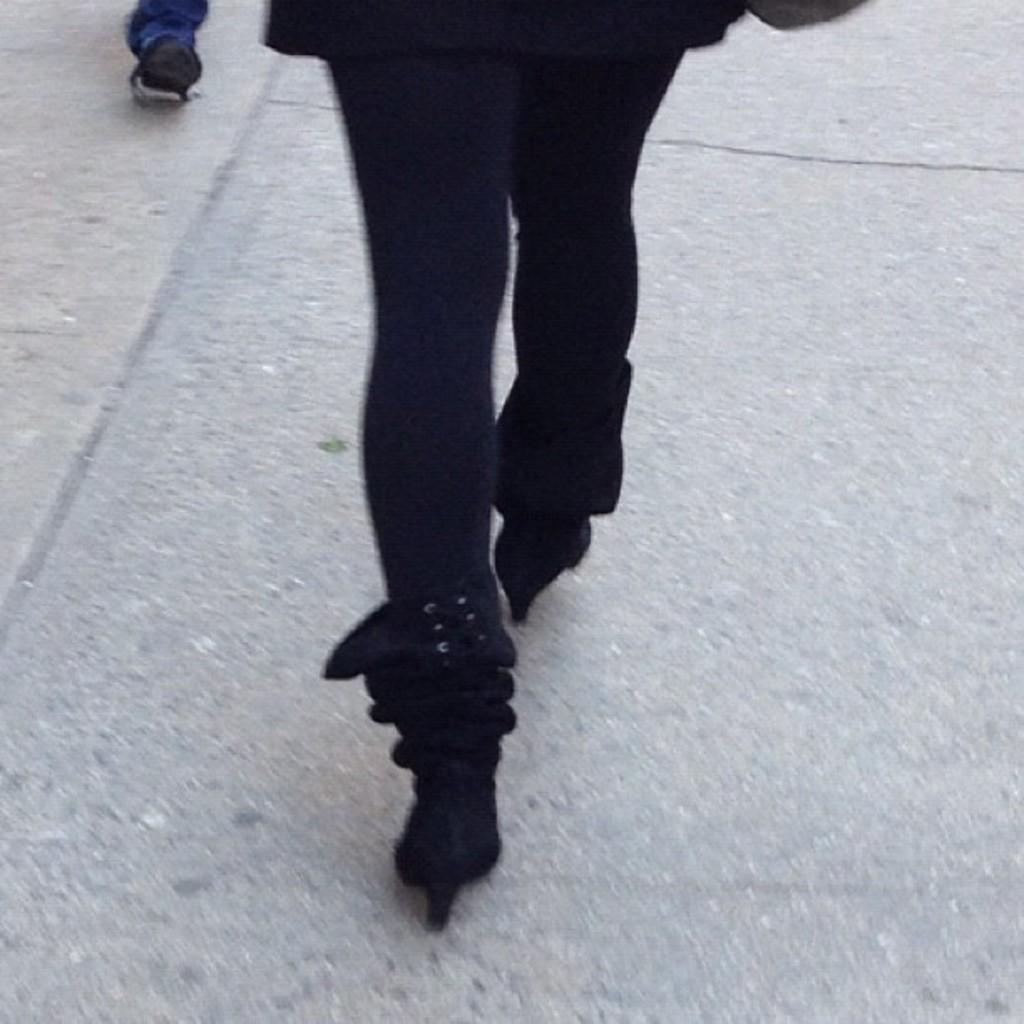What can be seen in the image? There is a person in the image. What type of clothing is the person wearing on their lower body? The person is wearing black pants. What type of footwear is the person wearing? The person is wearing black sandals. What is the person doing in the image? The person is walking on the road. Can you describe any other part of a person visible in the image? There is a leg of a person wearing a shoe in the left top of the image. What nation is represented by the star on the person's shirt in the image? There is no star visible on the person's shirt in the image. What type of cup is the person holding in the image? There is no cup present in the image. 